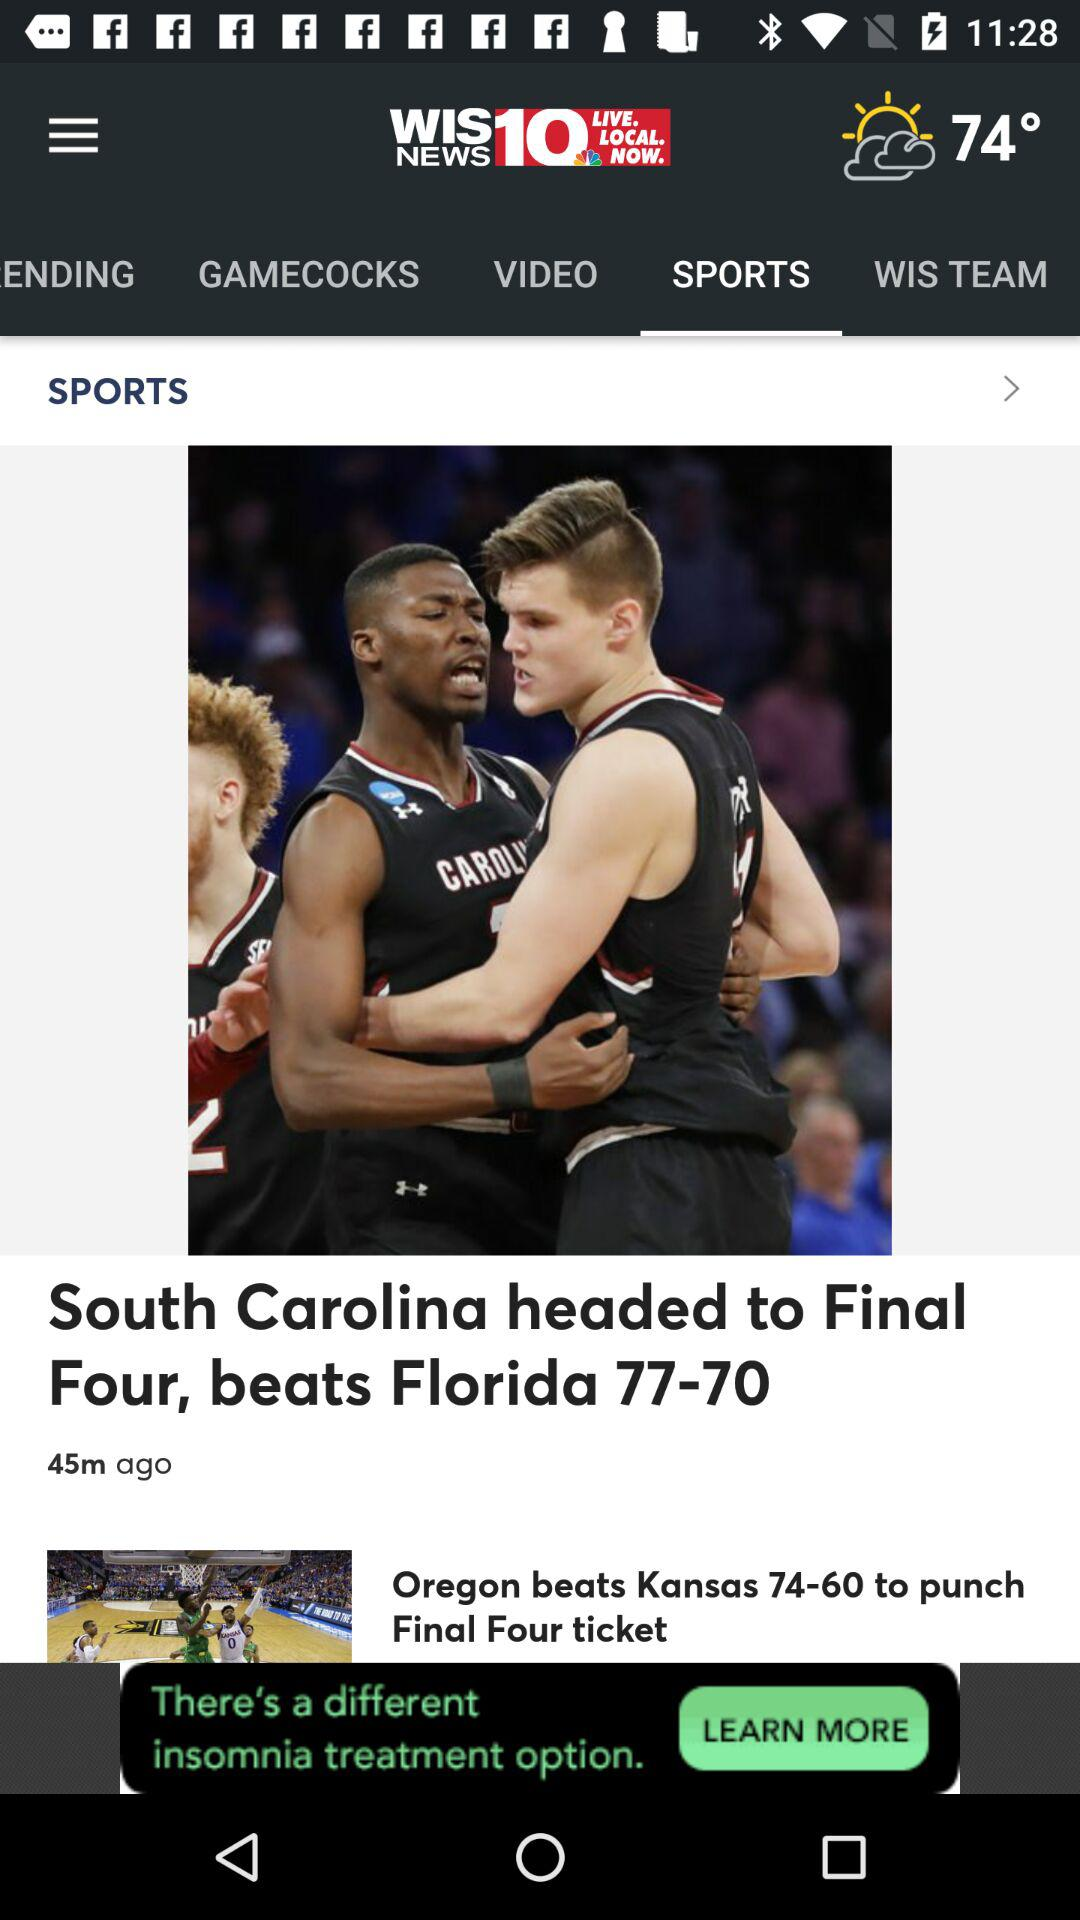Which team entered the last four?
When the provided information is insufficient, respond with <no answer>. <no answer> 